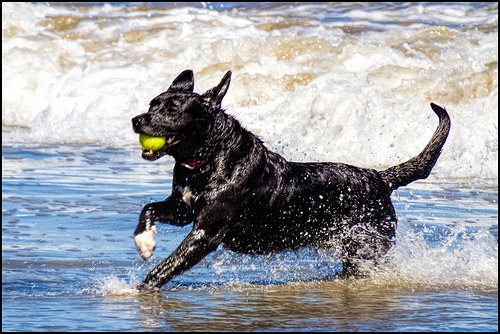<image>
Is there a dog under the ball? No. The dog is not positioned under the ball. The vertical relationship between these objects is different. Is there a ball behind the dog? No. The ball is not behind the dog. From this viewpoint, the ball appears to be positioned elsewhere in the scene. Is there a dog behind the ball? No. The dog is not behind the ball. From this viewpoint, the dog appears to be positioned elsewhere in the scene. Where is the ball in relation to the water? Is it in the water? No. The ball is not contained within the water. These objects have a different spatial relationship. Is the ball above the dog? No. The ball is not positioned above the dog. The vertical arrangement shows a different relationship. 